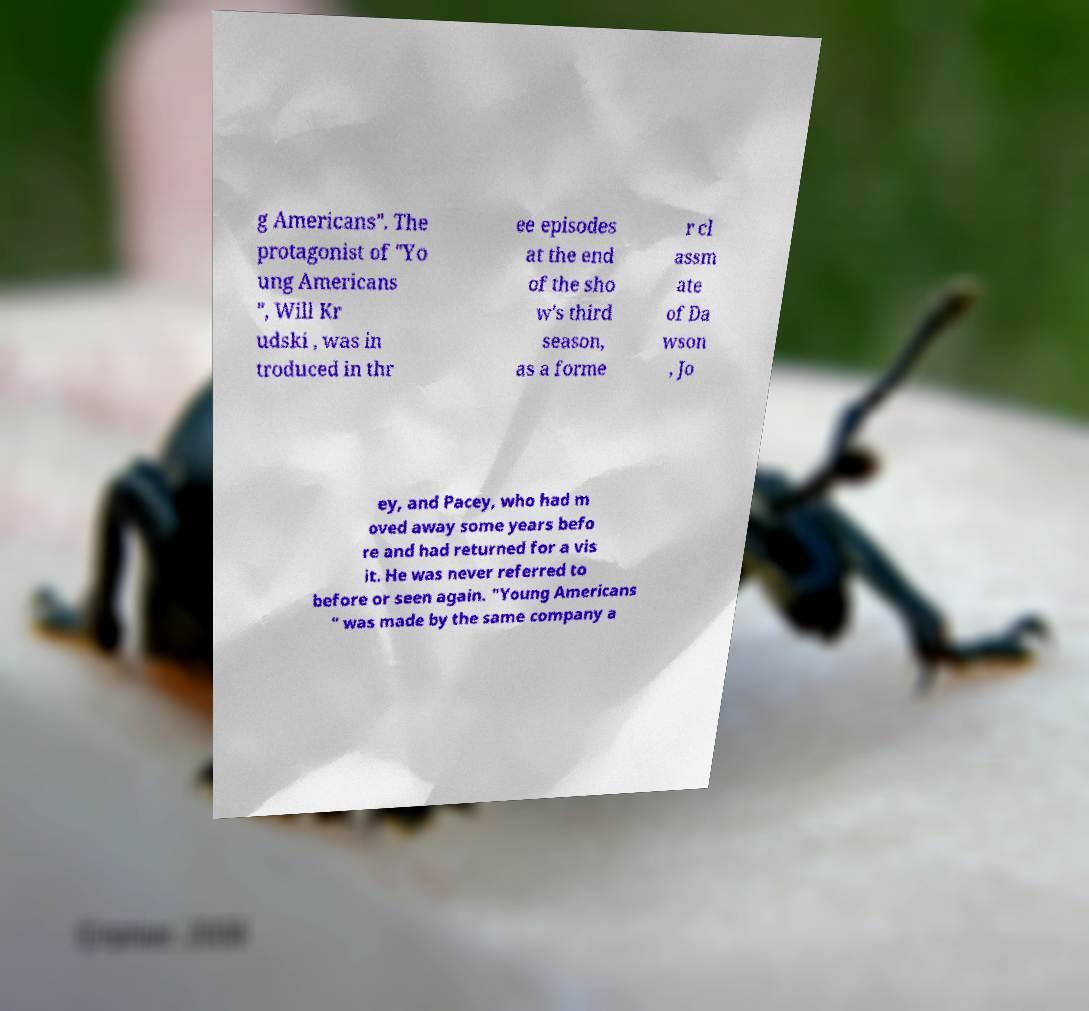Could you extract and type out the text from this image? g Americans". The protagonist of "Yo ung Americans ", Will Kr udski , was in troduced in thr ee episodes at the end of the sho w's third season, as a forme r cl assm ate of Da wson , Jo ey, and Pacey, who had m oved away some years befo re and had returned for a vis it. He was never referred to before or seen again. "Young Americans " was made by the same company a 